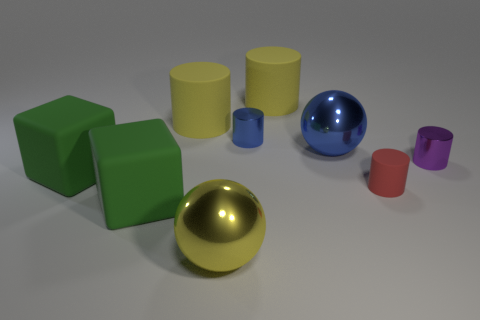Subtract 2 cylinders. How many cylinders are left? 3 Subtract all blue metallic cylinders. How many cylinders are left? 4 Subtract all blue cylinders. How many cylinders are left? 4 Subtract all green cylinders. Subtract all yellow spheres. How many cylinders are left? 5 Add 1 metal objects. How many objects exist? 10 Subtract all cubes. How many objects are left? 7 Add 2 small things. How many small things exist? 5 Subtract 1 blue balls. How many objects are left? 8 Subtract all big green things. Subtract all small red rubber cylinders. How many objects are left? 6 Add 4 large yellow matte things. How many large yellow matte things are left? 6 